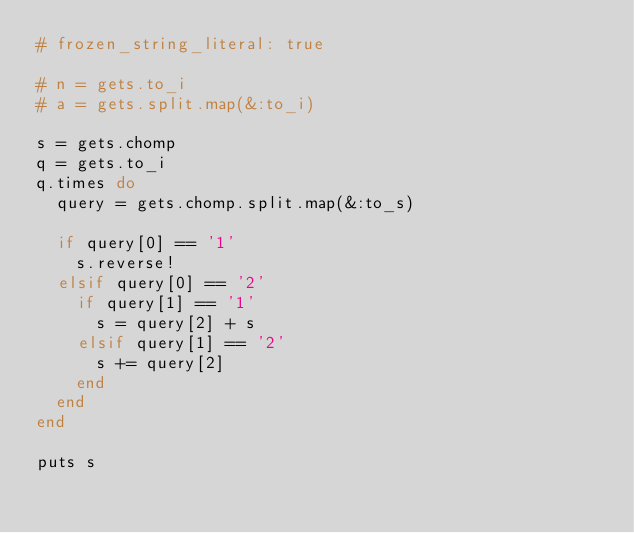Convert code to text. <code><loc_0><loc_0><loc_500><loc_500><_Ruby_># frozen_string_literal: true

# n = gets.to_i
# a = gets.split.map(&:to_i)

s = gets.chomp
q = gets.to_i
q.times do
  query = gets.chomp.split.map(&:to_s)

  if query[0] == '1'
    s.reverse!
  elsif query[0] == '2'
    if query[1] == '1'
      s = query[2] + s
    elsif query[1] == '2'
      s += query[2]
    end
  end
end

puts s
</code> 